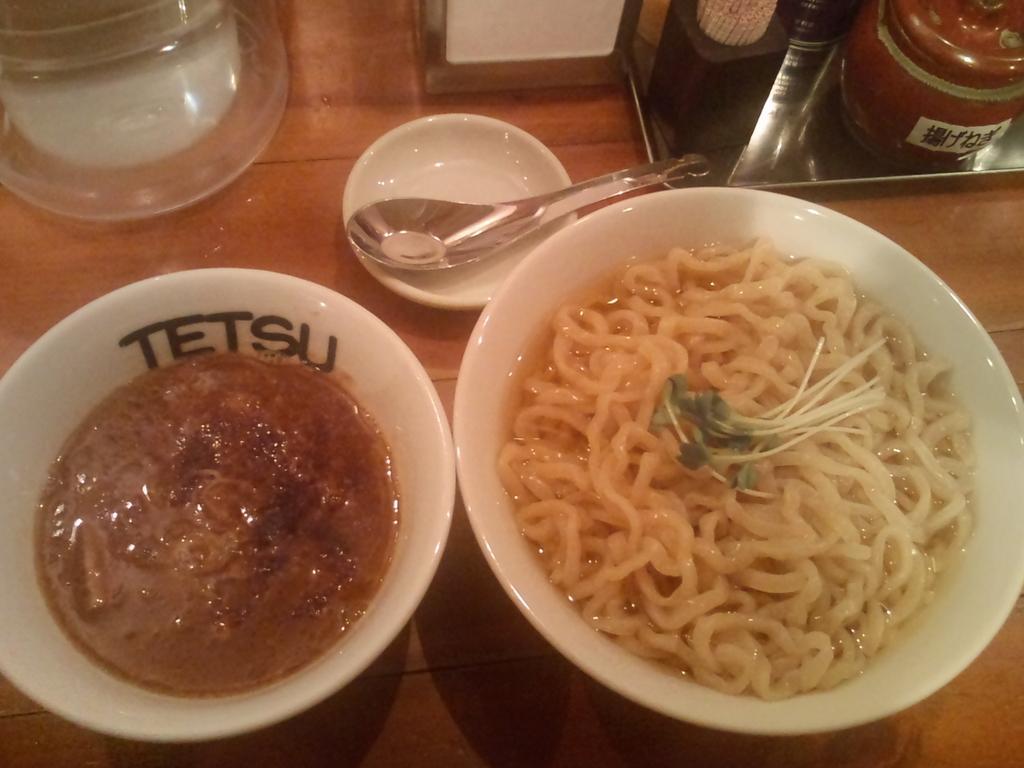In one or two sentences, can you explain what this image depicts? Here I can see a table on which few bowls, spoon, tissue papers and some other objects are placed. In the bowls, I can see some food items. 